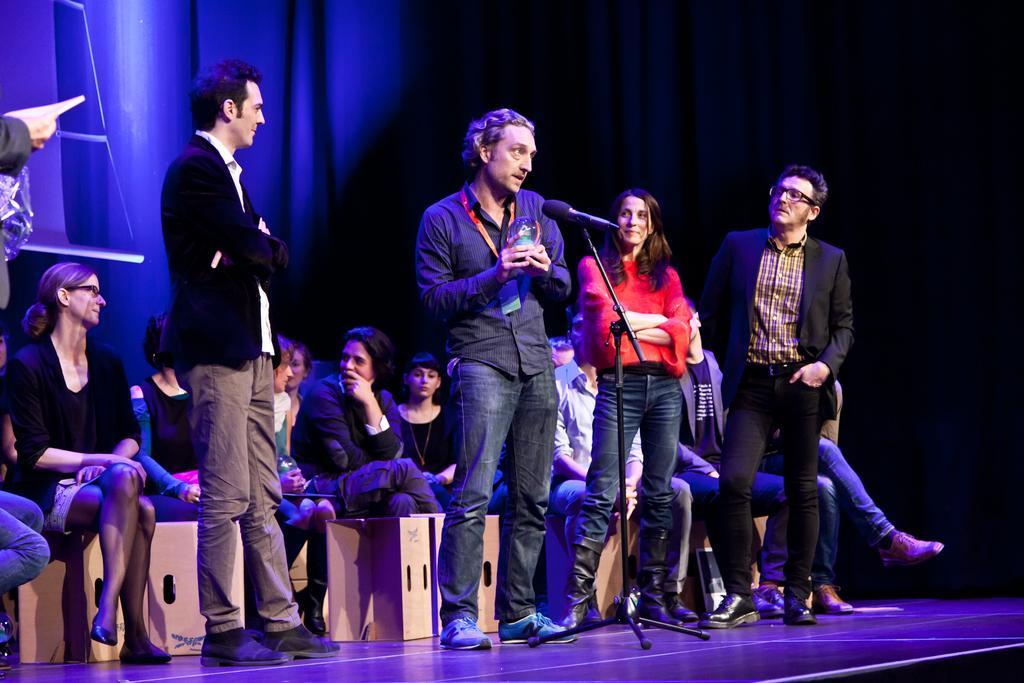Can you describe this image briefly? In the image we can see there are people sitting and some of them are standing, they are wearing clothes and some of them are wearing shoes and spectacles. Here we can see the microphone and the curtains. And few people are holding objects in their hands. 